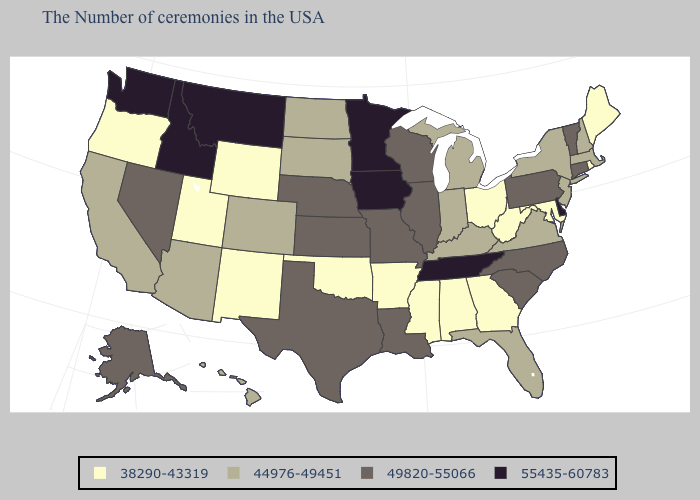Does Delaware have the same value as Colorado?
Keep it brief. No. Name the states that have a value in the range 38290-43319?
Give a very brief answer. Maine, Rhode Island, Maryland, West Virginia, Ohio, Georgia, Alabama, Mississippi, Arkansas, Oklahoma, Wyoming, New Mexico, Utah, Oregon. Name the states that have a value in the range 44976-49451?
Answer briefly. Massachusetts, New Hampshire, New York, New Jersey, Virginia, Florida, Michigan, Kentucky, Indiana, South Dakota, North Dakota, Colorado, Arizona, California, Hawaii. Name the states that have a value in the range 55435-60783?
Answer briefly. Delaware, Tennessee, Minnesota, Iowa, Montana, Idaho, Washington. What is the highest value in the USA?
Keep it brief. 55435-60783. What is the value of Maine?
Concise answer only. 38290-43319. Which states have the lowest value in the South?
Quick response, please. Maryland, West Virginia, Georgia, Alabama, Mississippi, Arkansas, Oklahoma. What is the value of West Virginia?
Write a very short answer. 38290-43319. Does the map have missing data?
Be succinct. No. Does Vermont have the lowest value in the USA?
Quick response, please. No. Does Delaware have the lowest value in the USA?
Short answer required. No. Which states have the lowest value in the MidWest?
Answer briefly. Ohio. What is the highest value in states that border Arizona?
Answer briefly. 49820-55066. Does Delaware have the highest value in the South?
Quick response, please. Yes. Name the states that have a value in the range 38290-43319?
Quick response, please. Maine, Rhode Island, Maryland, West Virginia, Ohio, Georgia, Alabama, Mississippi, Arkansas, Oklahoma, Wyoming, New Mexico, Utah, Oregon. 